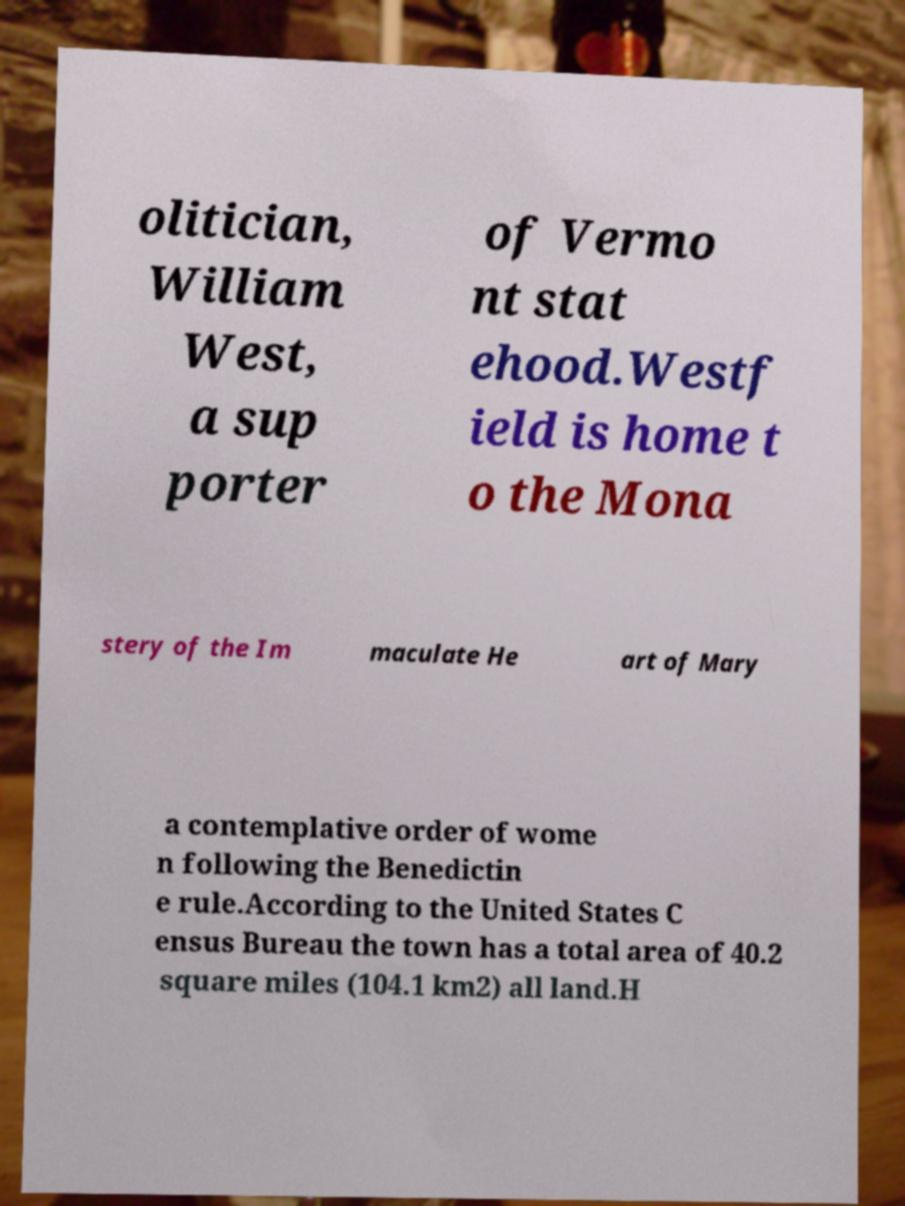Can you read and provide the text displayed in the image?This photo seems to have some interesting text. Can you extract and type it out for me? olitician, William West, a sup porter of Vermo nt stat ehood.Westf ield is home t o the Mona stery of the Im maculate He art of Mary a contemplative order of wome n following the Benedictin e rule.According to the United States C ensus Bureau the town has a total area of 40.2 square miles (104.1 km2) all land.H 